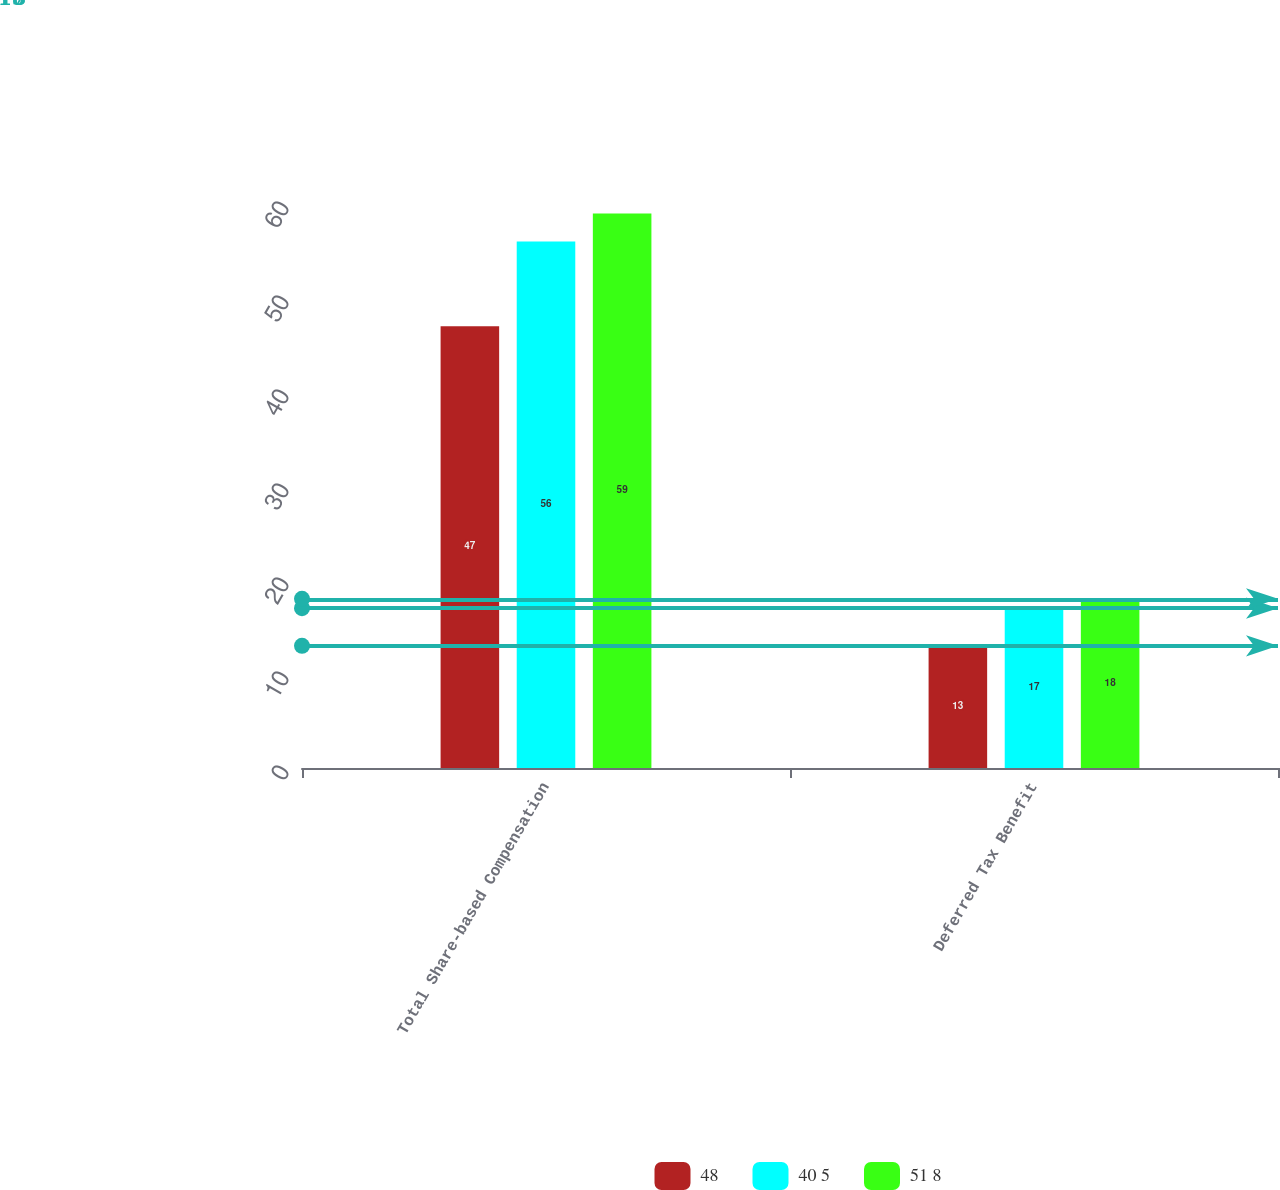Convert chart to OTSL. <chart><loc_0><loc_0><loc_500><loc_500><stacked_bar_chart><ecel><fcel>Total Share-based Compensation<fcel>Deferred Tax Benefit<nl><fcel>48<fcel>47<fcel>13<nl><fcel>40 5<fcel>56<fcel>17<nl><fcel>51 8<fcel>59<fcel>18<nl></chart> 